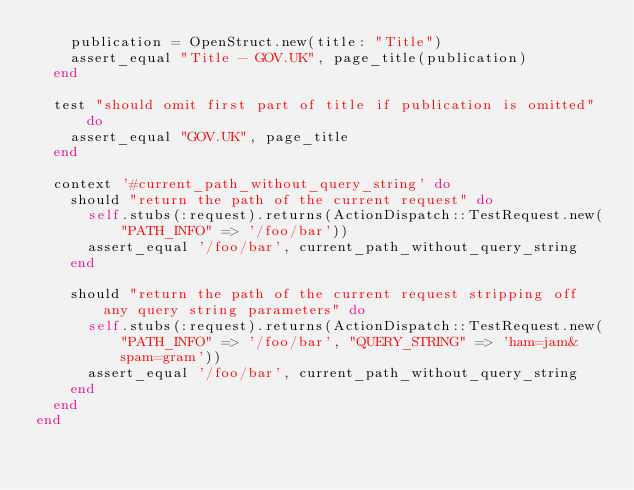<code> <loc_0><loc_0><loc_500><loc_500><_Ruby_>    publication = OpenStruct.new(title: "Title")
    assert_equal "Title - GOV.UK", page_title(publication)
  end

  test "should omit first part of title if publication is omitted" do
    assert_equal "GOV.UK", page_title
  end

  context '#current_path_without_query_string' do
    should "return the path of the current request" do
      self.stubs(:request).returns(ActionDispatch::TestRequest.new("PATH_INFO" => '/foo/bar'))
      assert_equal '/foo/bar', current_path_without_query_string
    end

    should "return the path of the current request stripping off any query string parameters" do
      self.stubs(:request).returns(ActionDispatch::TestRequest.new("PATH_INFO" => '/foo/bar', "QUERY_STRING" => 'ham=jam&spam=gram'))
      assert_equal '/foo/bar', current_path_without_query_string
    end
  end
end
</code> 